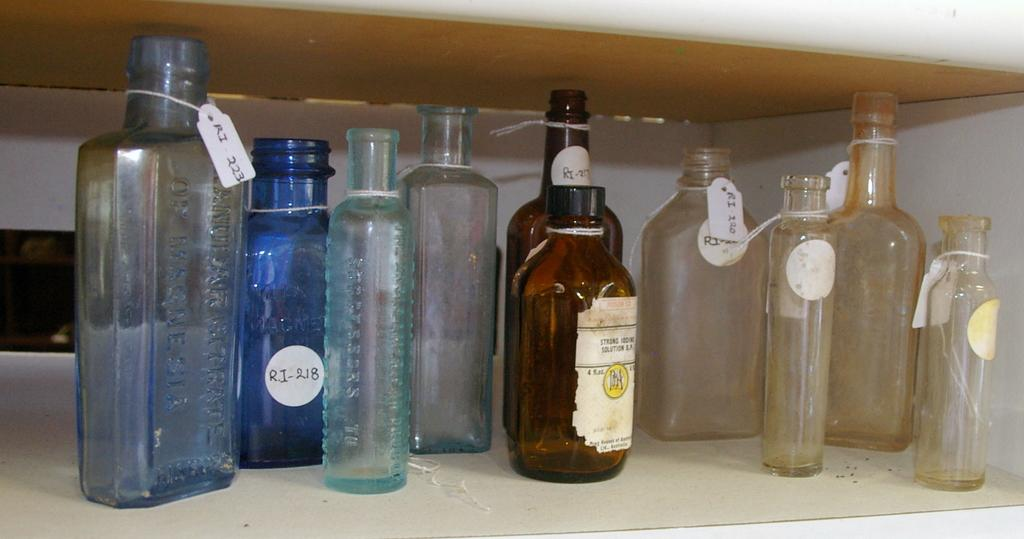<image>
Describe the image concisely. Several bottles with labels ri-218 and ri-223 on it. 